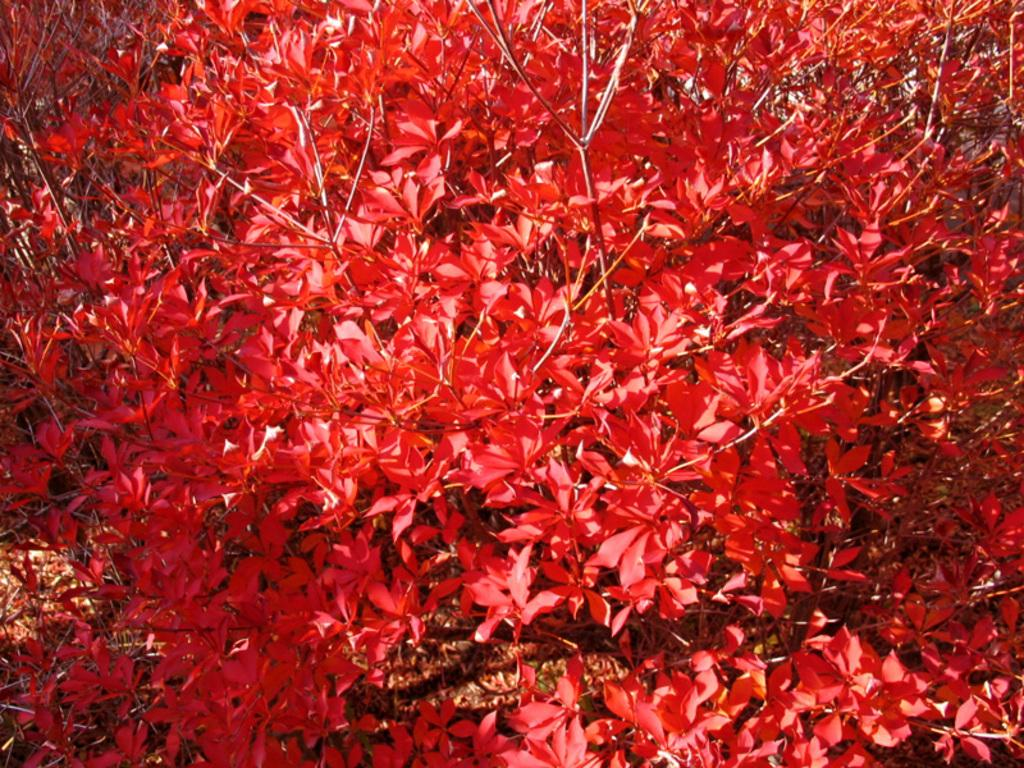What is depicted in the image? The image contains atoms. What feature do the atoms have? The atoms have red leaves. How many flowers are present in the image? There are no flowers present in the image; it features atoms with red leaves. What type of chess piece can be seen in the image? There is no chess piece present in the image; it features atoms with red leaves. 